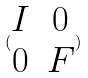Convert formula to latex. <formula><loc_0><loc_0><loc_500><loc_500>( \begin{matrix} I & 0 \\ 0 & F \end{matrix} )</formula> 